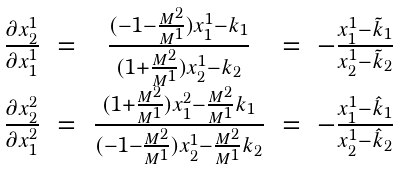<formula> <loc_0><loc_0><loc_500><loc_500>\begin{array} { c c c c c } \frac { \partial x ^ { 1 } _ { 2 } } { \partial x ^ { 1 } _ { 1 } } & = & \frac { ( - 1 - \frac { M ^ { 2 } } { M ^ { 1 } } ) x ^ { 1 } _ { 1 } - k _ { 1 } } { ( 1 + \frac { M ^ { 2 } } { M ^ { 1 } } ) x ^ { 1 } _ { 2 } - k _ { 2 } } & = & - \frac { x ^ { 1 } _ { 1 } - \tilde { k } _ { 1 } } { x ^ { 1 } _ { 2 } - \tilde { k } _ { 2 } } \\ \frac { \partial x ^ { 2 } _ { 2 } } { \partial x ^ { 2 } _ { 1 } } & = & \frac { ( 1 + \frac { M ^ { 2 } } { M ^ { 1 } } ) x ^ { 2 } _ { 1 } - \frac { M ^ { 2 } } { M ^ { 1 } } k _ { 1 } } { ( - 1 - \frac { M ^ { 2 } } { M ^ { 1 } } ) x ^ { 1 } _ { 2 } - \frac { M ^ { 2 } } { M ^ { 1 } } k _ { 2 } } & = & - \frac { x ^ { 1 } _ { 1 } - \hat { k } _ { 1 } } { x ^ { 1 } _ { 2 } - \hat { k } _ { 2 } } \end{array}</formula> 